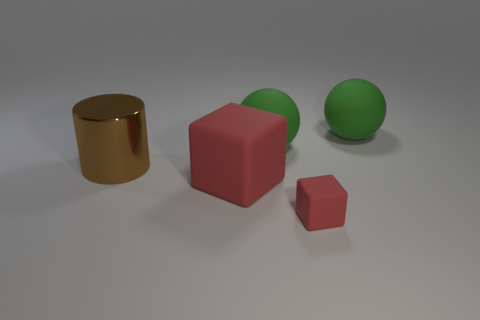Add 3 red objects. How many objects exist? 8 Subtract all blocks. How many objects are left? 3 Subtract all tiny gray shiny blocks. Subtract all brown cylinders. How many objects are left? 4 Add 1 large green matte spheres. How many large green matte spheres are left? 3 Add 3 big shiny cylinders. How many big shiny cylinders exist? 4 Subtract 0 cyan cylinders. How many objects are left? 5 